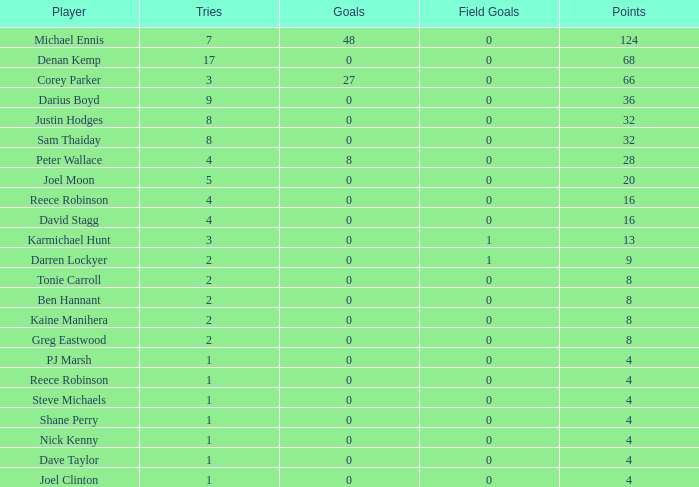What is the number of goals Dave Taylor, who has more than 1 tries, has? None. 